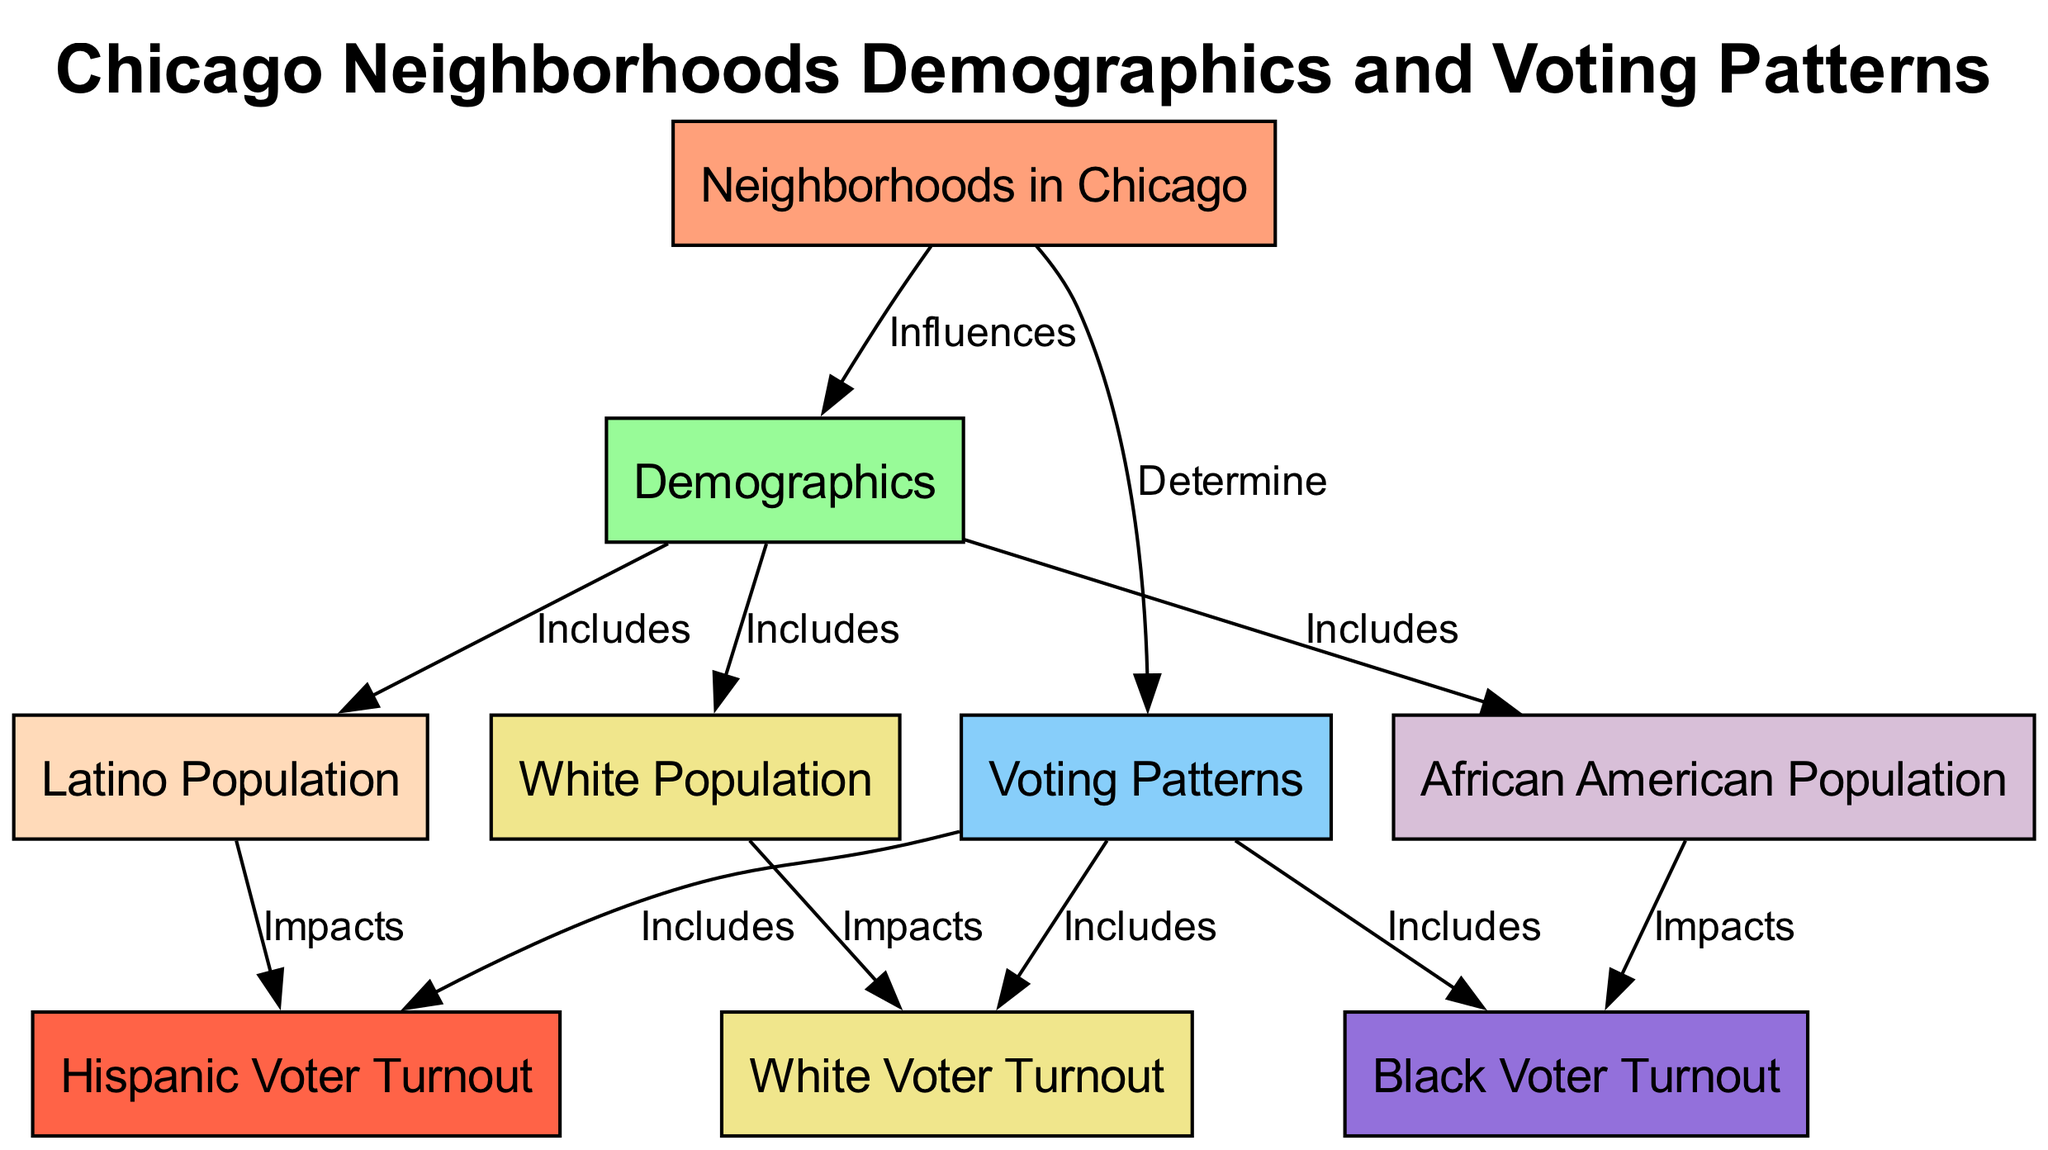What are the three main population categories included in the demographics? The demographics node includes three specific population categories: Latino, African American, and White populations, as shown in the edges connecting demographics to these populations.
Answer: Latino, African American, White How do neighborhoods influence voting patterns? The diagram indicates that neighborhoods determine voting patterns, which implies that the characteristics and demographics of a neighborhood can affect how its residents vote.
Answer: Determine What impacts Hispanic voter turnout? Hispanic voter turnout is impacted by the Latino population, as illustrated by the edge from latino_population to hispanic_voter_turnout showing a direct influence.
Answer: Latino Population How many edges are there connecting neighborhood demographics and voting patterns? By recounting the edges, we can see that there are six edges connecting demographics to voting patterns, indicating various relationships and impacts.
Answer: Six What is the relationship between the African American population and black voter turnout? The connection from african_american_population to black_voter_turnout shows that the African American population directly impacts black voter turnout, demonstrating their interdependence in the diagram.
Answer: Impacts Which population category has the highest voter turnout? To determine this, we must analyze the voter turnout nodes, which are influenced by their respective populations. The diagram does suggest that specific populations correlate with higher voter turnout rates among different racial groups, which may require additional information outside the diagram.
Answer: Not determinable from diagram What color represents the white population in the diagram? The color assigned to the white population in the diagram is a certain shade of yellow, which corresponds specifically to the node labeled as white_population.
Answer: F0E68C 